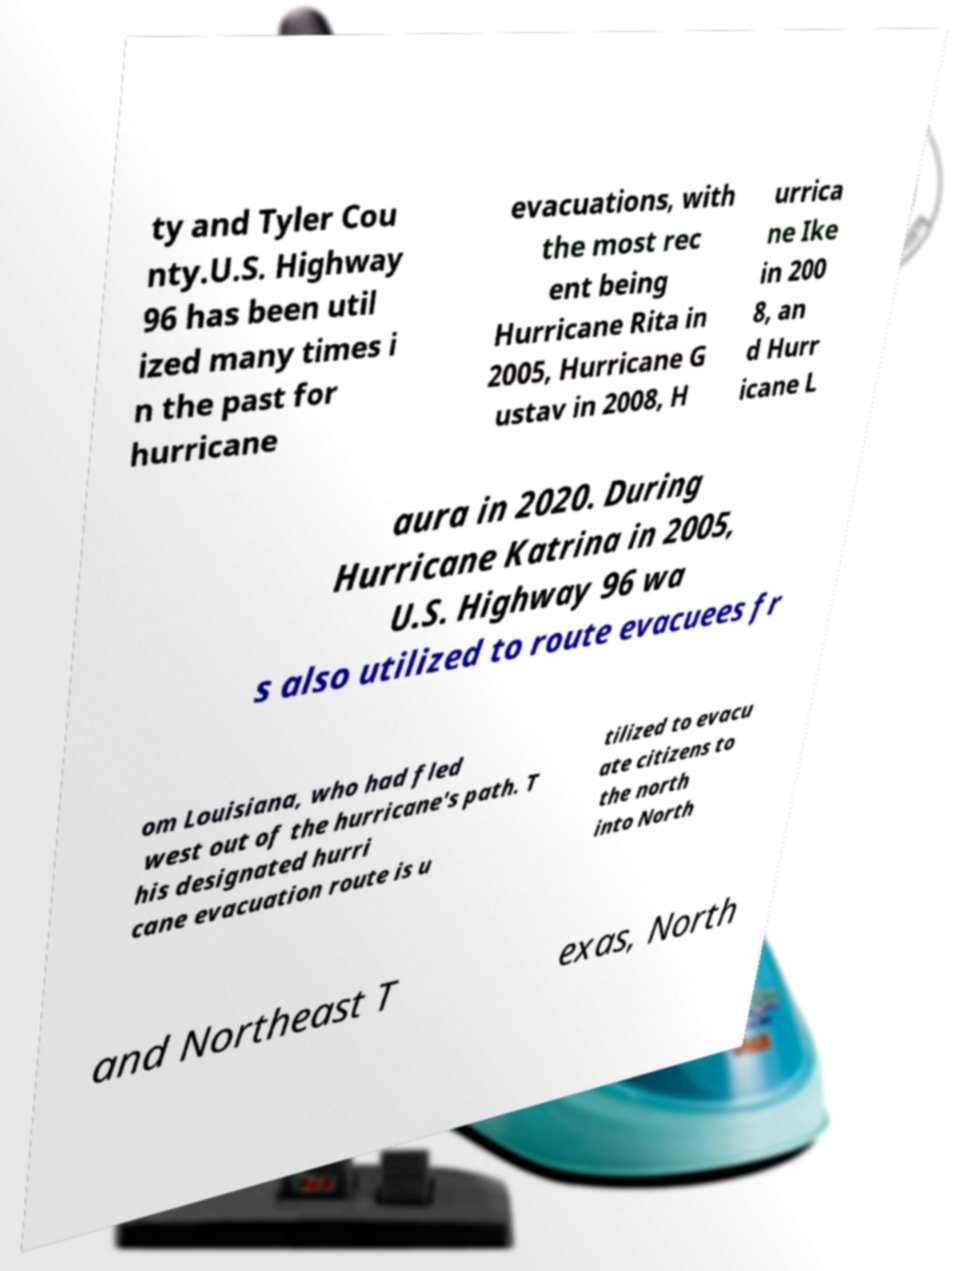For documentation purposes, I need the text within this image transcribed. Could you provide that? ty and Tyler Cou nty.U.S. Highway 96 has been util ized many times i n the past for hurricane evacuations, with the most rec ent being Hurricane Rita in 2005, Hurricane G ustav in 2008, H urrica ne Ike in 200 8, an d Hurr icane L aura in 2020. During Hurricane Katrina in 2005, U.S. Highway 96 wa s also utilized to route evacuees fr om Louisiana, who had fled west out of the hurricane's path. T his designated hurri cane evacuation route is u tilized to evacu ate citizens to the north into North and Northeast T exas, North 